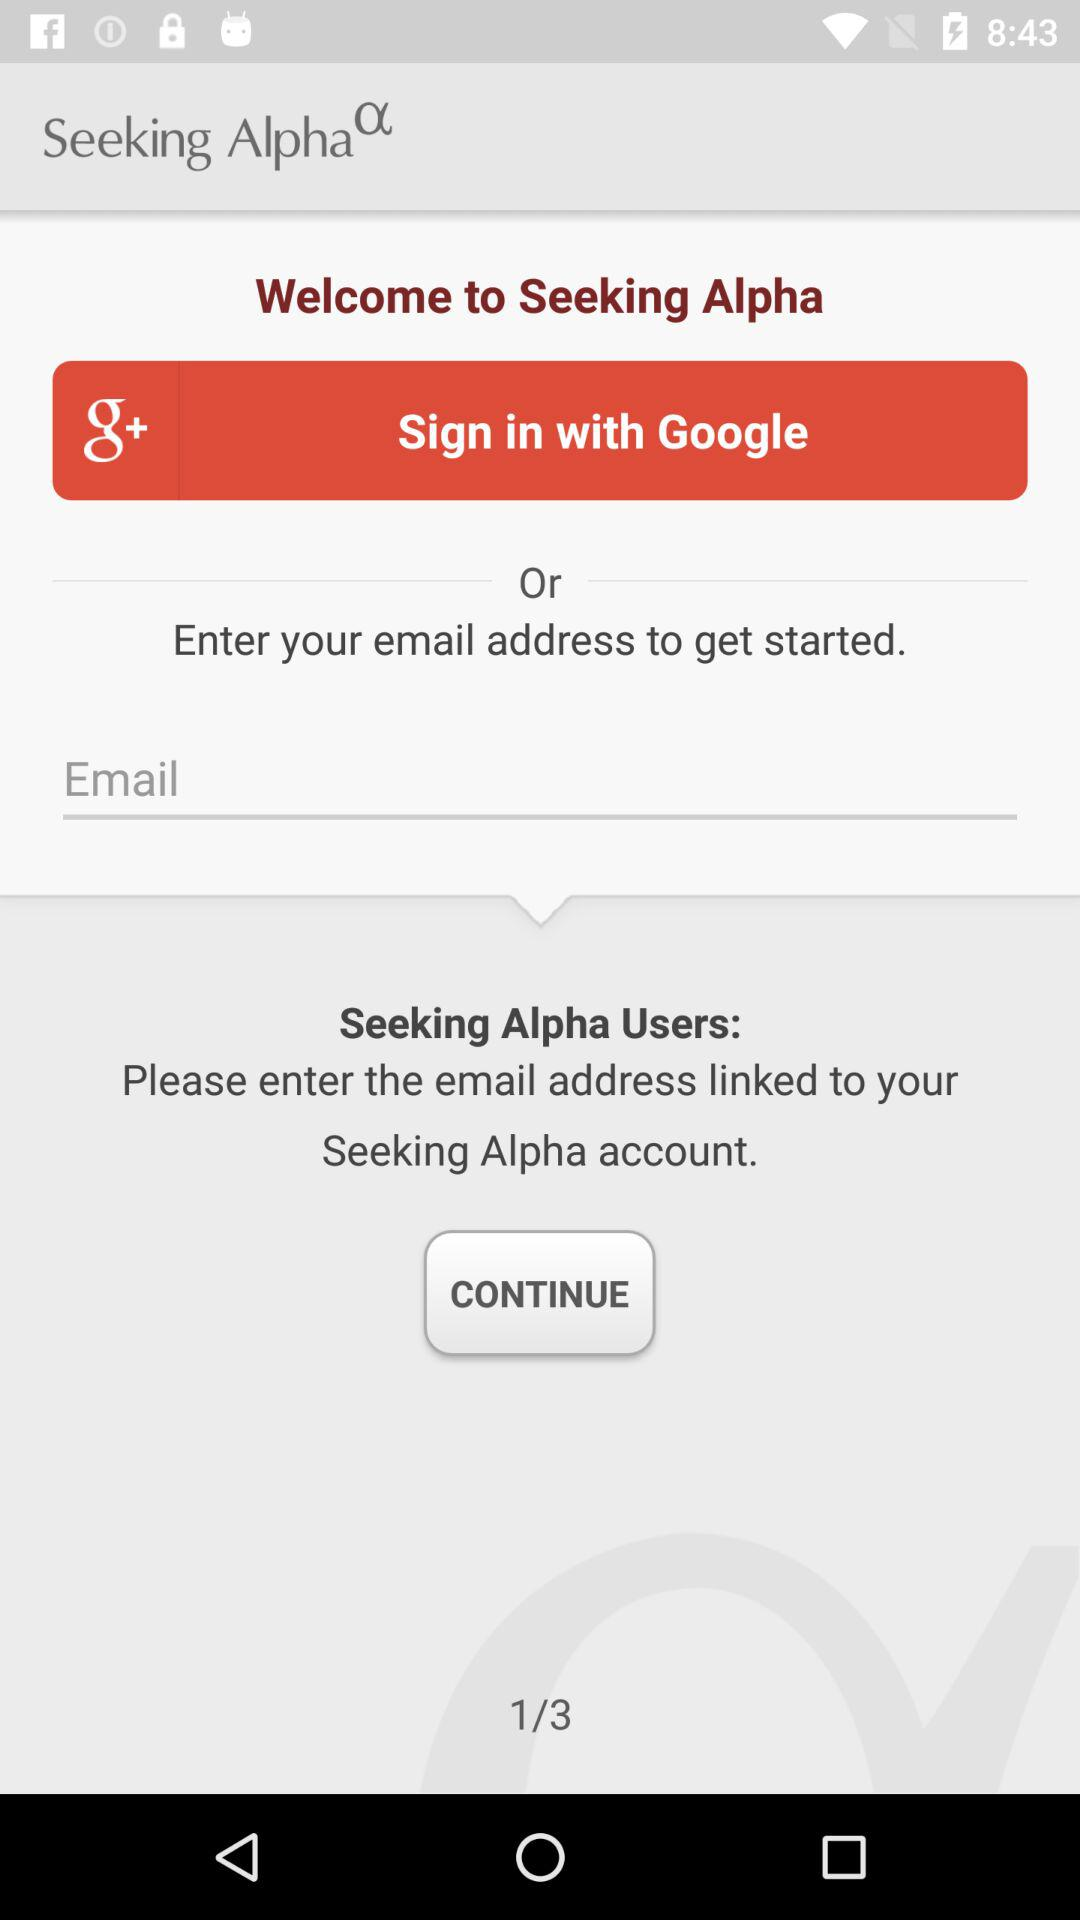Which accounts can I use to sign in? You can use "Google+" and "Email" accounts to sign in. 